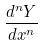<formula> <loc_0><loc_0><loc_500><loc_500>\frac { d ^ { n } Y } { d x ^ { n } }</formula> 